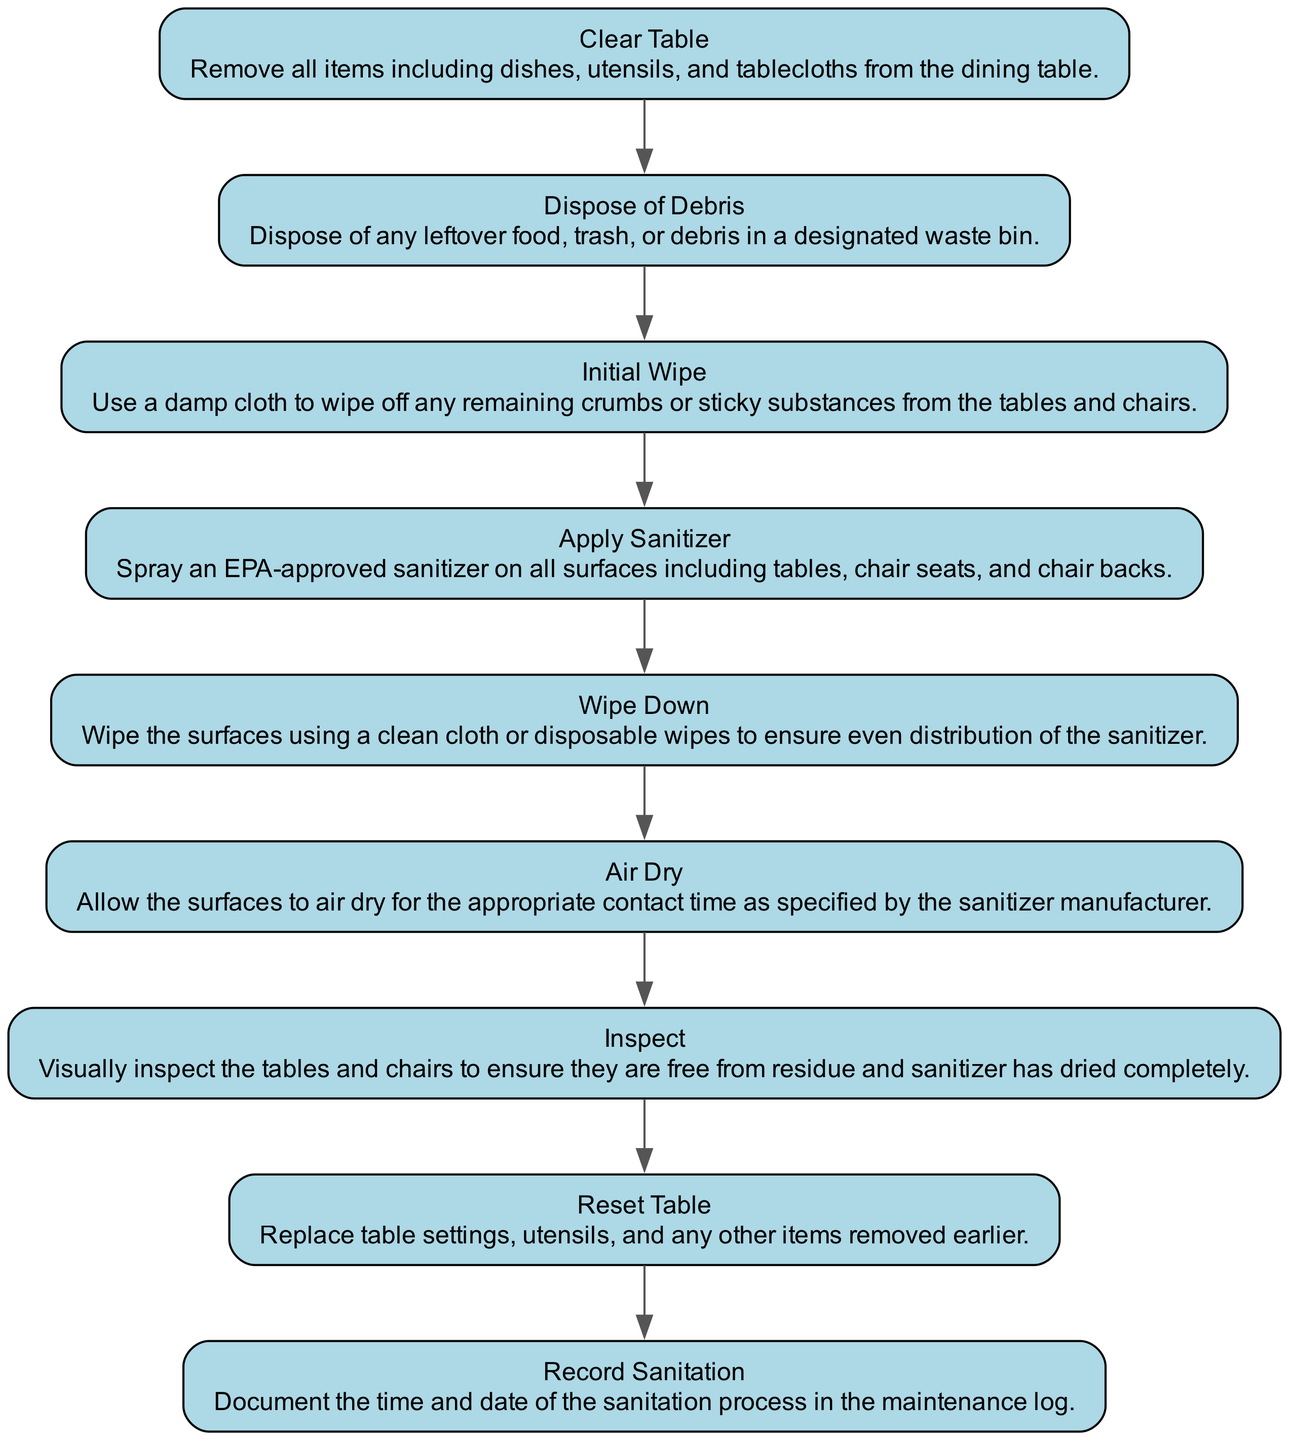What is the first step to sanitize dining tables and chairs? The diagram indicates that the first step is "Clear Table," which involves removing all items from the dining table.
Answer: Clear Table How many steps are there in the sanitation process? By counting the steps in the diagram, I find there are a total of nine distinct steps outlined for sanitizing the dining tables and chairs.
Answer: 9 What do you do after applying the sanitizer? According to the flow chart, after "Apply Sanitizer," the next step is "Wipe Down," which involves using a clean cloth to ensure even distribution of the sanitizer.
Answer: Wipe Down What is the last step in the sanitation process? The final step of the process, as shown in the diagram, is "Record Sanitation," where the time and date of the sanitation process are documented.
Answer: Record Sanitation What step comes immediately before 'Inspect'? Looking at the sequence in the diagram, the step that comes right before 'Inspect' is 'Air Dry,' which involves allowing surfaces to dry for the appropriate contact time.
Answer: Air Dry How many steps involve a physical action (like wiping or applying)? A review of the diagram shows that there are four steps that involve a physical action: "Initial Wipe," "Apply Sanitizer," "Wipe Down," and "Clear Table."
Answer: 4 What action should be taken if residue is found during the 'Inspect' step? Though not explicitly stated in the diagram, generally after 'Inspect,' if residue is detected, one should likely reapply the sanitizer or wipe down again to ensure cleanliness.
Answer: Reapply sanitizer What is done with leftover food during the sanitation process? The diagram specifies in the "Dispose of Debris" step that leftover food, trash, or debris should be disposed of in a designated waste bin.
Answer: Dispose of Debris What is the purpose of 'Air Dry' step? The 'Air Dry' step is essential for allowing the surfaces to dry for the appropriate contact time specified by the sanitizer manufacturer.
Answer: Allow drying 